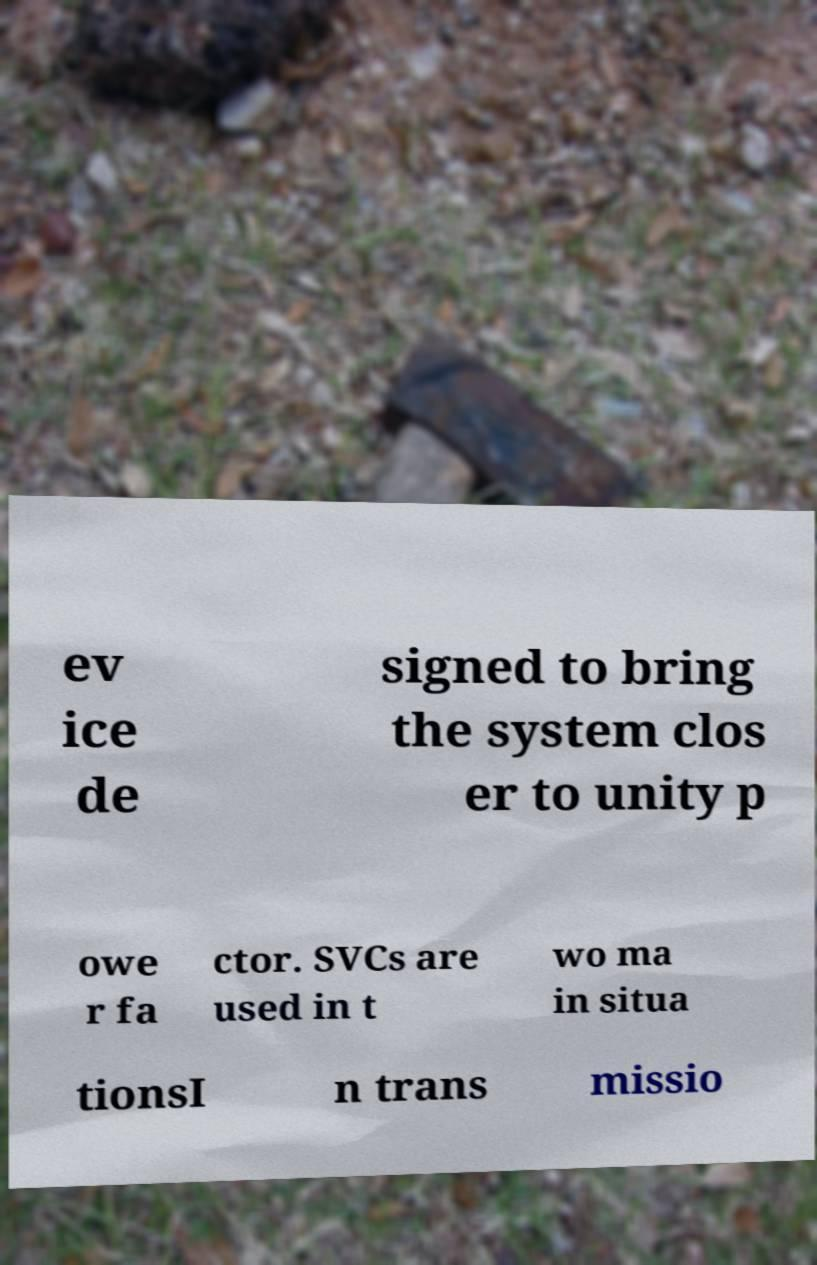Please read and relay the text visible in this image. What does it say? ev ice de signed to bring the system clos er to unity p owe r fa ctor. SVCs are used in t wo ma in situa tionsI n trans missio 